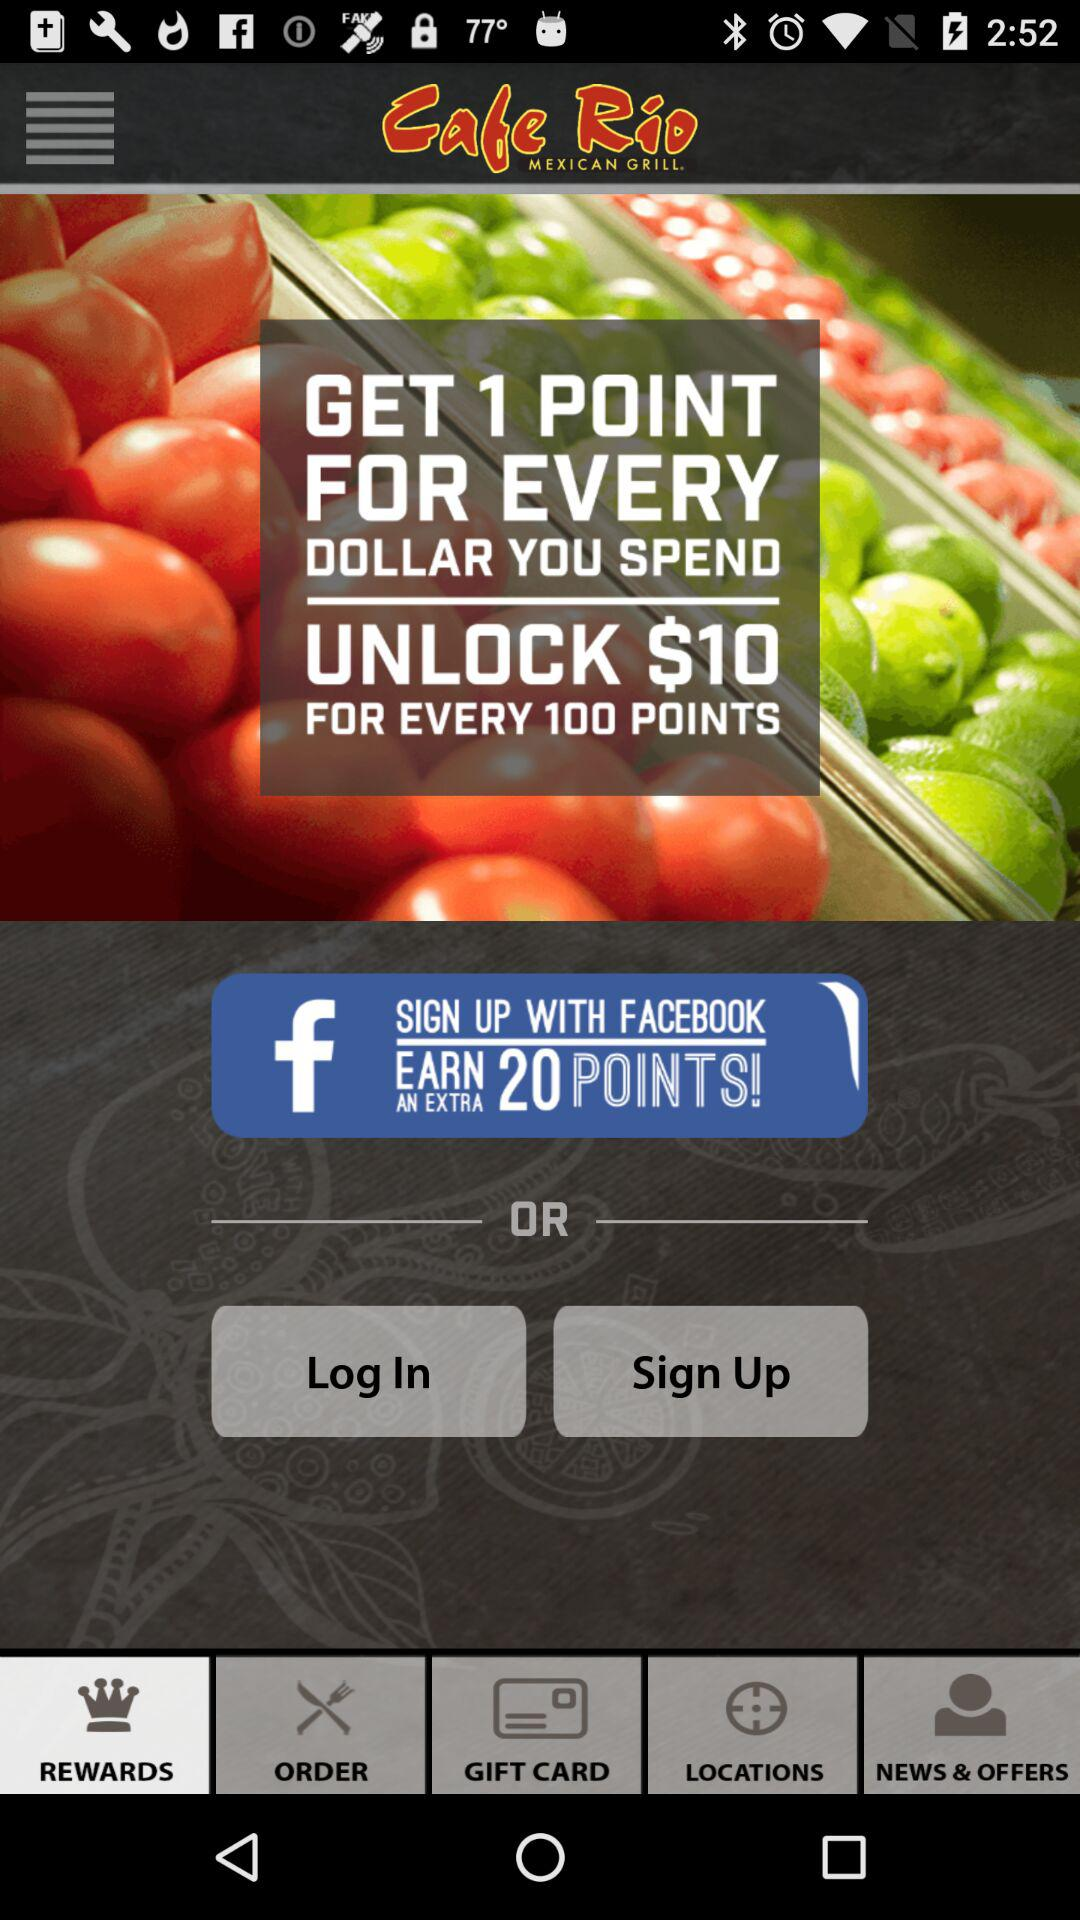How many points do I need to earn to get a $10 reward?
Answer the question using a single word or phrase. 100 